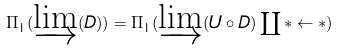Convert formula to latex. <formula><loc_0><loc_0><loc_500><loc_500>\Pi _ { 1 } ( \varinjlim ( D ) ) = \Pi _ { 1 } ( \varinjlim ( U \circ D ) \coprod * \leftarrow * )</formula> 